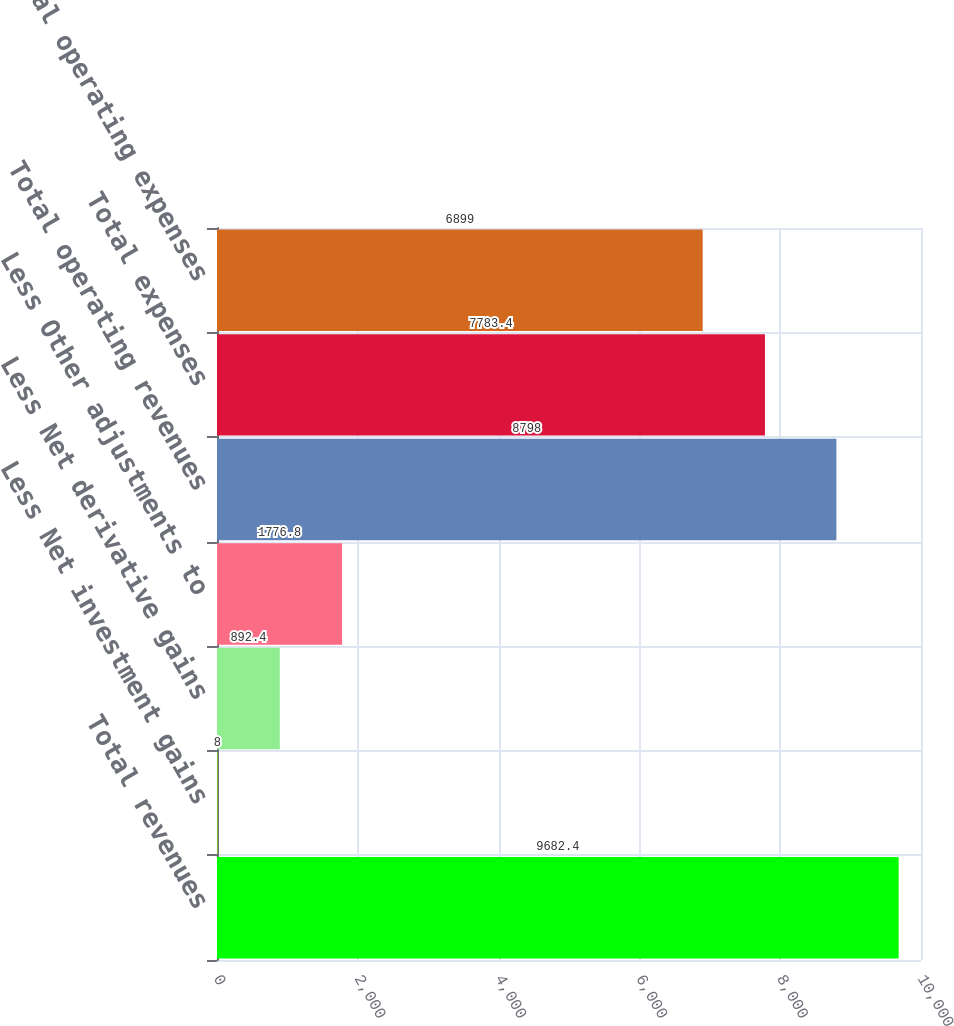Convert chart. <chart><loc_0><loc_0><loc_500><loc_500><bar_chart><fcel>Total revenues<fcel>Less Net investment gains<fcel>Less Net derivative gains<fcel>Less Other adjustments to<fcel>Total operating revenues<fcel>Total expenses<fcel>Total operating expenses<nl><fcel>9682.4<fcel>8<fcel>892.4<fcel>1776.8<fcel>8798<fcel>7783.4<fcel>6899<nl></chart> 